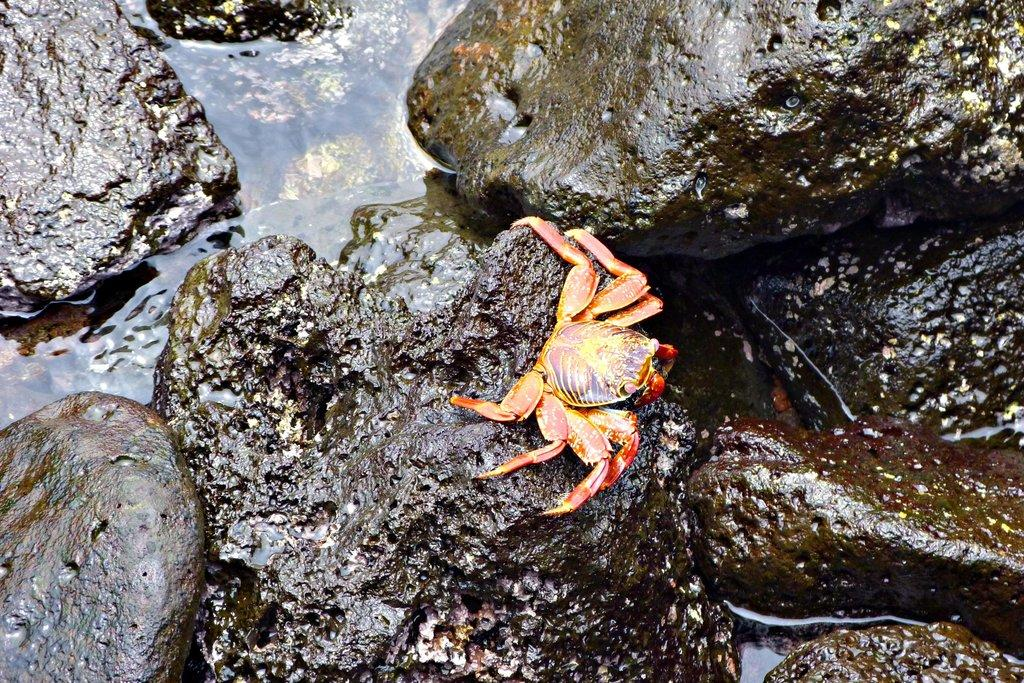What is the main subject of the image? There is a scorpion in the image. What colors can be seen on the scorpion? The scorpion is in brown and orange colors. Where is the scorpion located? The scorpion is on a rock. What else can be seen in the image besides the scorpion? There is water visible in the image. What type of music does the scorpion's son enjoy listening to in the image? There is no mention of a son or music in the image; it features a scorpion on a rock with water visible in the background. 